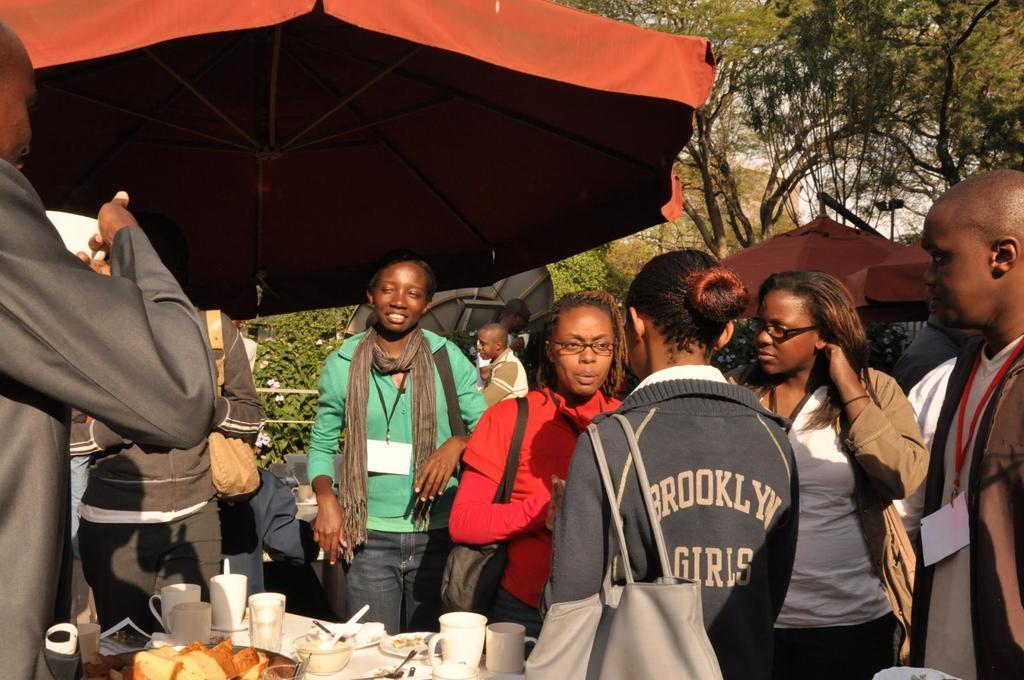How would you summarize this image in a sentence or two? In this picture I can see cups, plates and some other objects on the table, there are group of people standing, there are umbrellas, and in the background there are trees and there is the sky. 